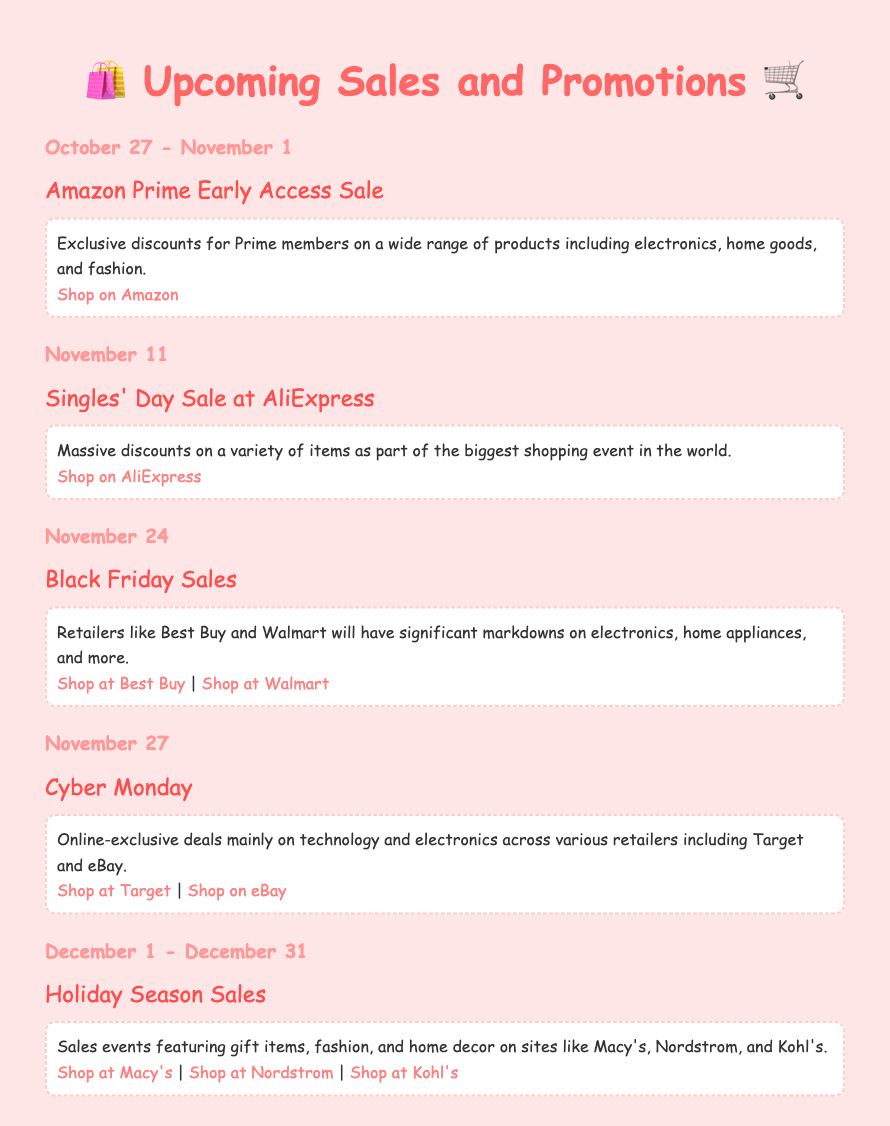What is the date range for the Amazon Prime Sale? The document states the date range for the Amazon Prime Early Access Sale is October 27 - November 1.
Answer: October 27 - November 1 What major shopping event occurs on November 11? The document mentions that on November 11, the Singles' Day Sale occurs at AliExpress.
Answer: Singles' Day Sale Which retailers are mentioned for Black Friday Sales? The document specifies that Best Buy and Walmart will have significant markdowns on Black Friday.
Answer: Best Buy and Walmart What type of items are primarily discounted during Cyber Monday? The document indicates that Cyber Monday features online-exclusive deals mainly on technology and electronics.
Answer: Technology and electronics When do Holiday Season Sales start and end? According to the document, the Holiday Season Sales run from December 1 to December 31.
Answer: December 1 - December 31 What is the main focus of the Holiday Season Sales? The document highlights that the Holiday Season Sales feature gift items, fashion, and home decor.
Answer: Gift items, fashion, and home decor Which sale offers exclusive discounts for Prime members? The document specifies that the Amazon Prime Early Access Sale offers exclusive discounts for Prime members.
Answer: Amazon Prime Early Access Sale What is the website link for shopping at Target during Cyber Monday? The document provides the link to shop at Target during Cyber Monday.
Answer: https://www.target.com How many websites are listed for Holiday Season Sales? The document lists three websites for Holiday Season Sales: Macy's, Nordstrom, and Kohl's.
Answer: Three 